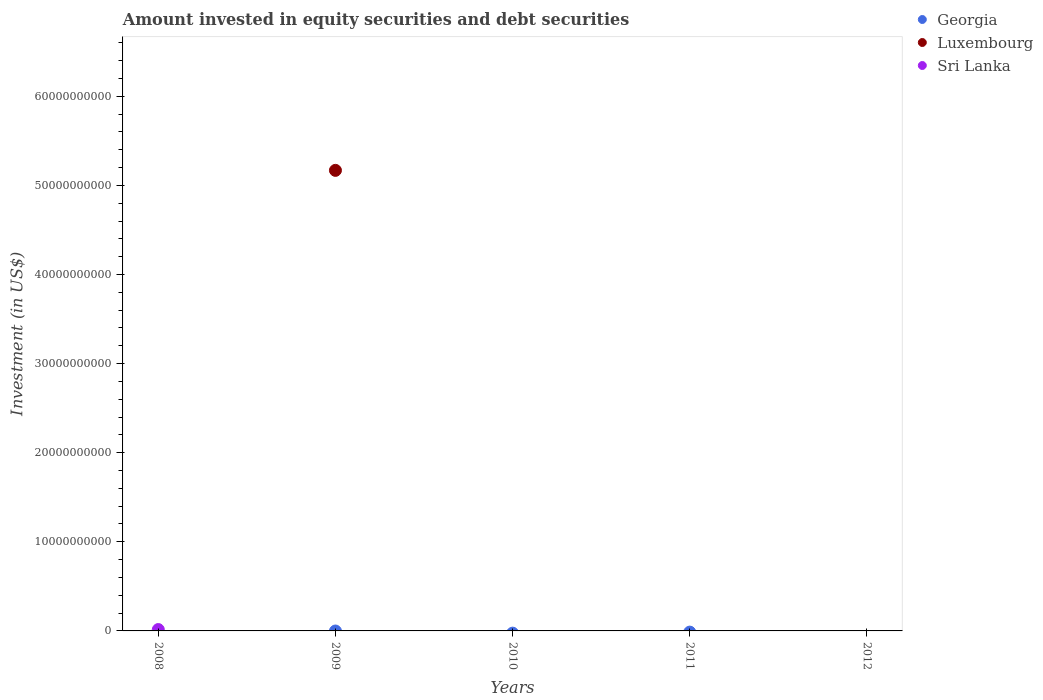Is the number of dotlines equal to the number of legend labels?
Ensure brevity in your answer.  No. What is the amount invested in equity securities and debt securities in Sri Lanka in 2012?
Offer a very short reply. 0. Across all years, what is the maximum amount invested in equity securities and debt securities in Luxembourg?
Provide a succinct answer. 5.17e+1. In which year was the amount invested in equity securities and debt securities in Sri Lanka maximum?
Provide a succinct answer. 2008. What is the total amount invested in equity securities and debt securities in Sri Lanka in the graph?
Give a very brief answer. 1.53e+08. What is the average amount invested in equity securities and debt securities in Luxembourg per year?
Give a very brief answer. 1.03e+1. What is the difference between the highest and the lowest amount invested in equity securities and debt securities in Luxembourg?
Offer a very short reply. 5.17e+1. Is the amount invested in equity securities and debt securities in Georgia strictly less than the amount invested in equity securities and debt securities in Luxembourg over the years?
Your answer should be compact. No. How many years are there in the graph?
Offer a terse response. 5. What is the difference between two consecutive major ticks on the Y-axis?
Your answer should be very brief. 1.00e+1. Are the values on the major ticks of Y-axis written in scientific E-notation?
Offer a terse response. No. Does the graph contain any zero values?
Provide a short and direct response. Yes. Does the graph contain grids?
Offer a very short reply. No. How are the legend labels stacked?
Provide a succinct answer. Vertical. What is the title of the graph?
Provide a short and direct response. Amount invested in equity securities and debt securities. What is the label or title of the Y-axis?
Your answer should be very brief. Investment (in US$). What is the Investment (in US$) of Sri Lanka in 2008?
Your response must be concise. 1.53e+08. What is the Investment (in US$) of Georgia in 2009?
Give a very brief answer. 0. What is the Investment (in US$) of Luxembourg in 2009?
Give a very brief answer. 5.17e+1. What is the Investment (in US$) in Sri Lanka in 2009?
Offer a very short reply. 0. What is the Investment (in US$) of Sri Lanka in 2010?
Ensure brevity in your answer.  0. What is the Investment (in US$) of Sri Lanka in 2011?
Give a very brief answer. 0. What is the Investment (in US$) in Luxembourg in 2012?
Provide a short and direct response. 0. What is the Investment (in US$) of Sri Lanka in 2012?
Your answer should be very brief. 0. Across all years, what is the maximum Investment (in US$) of Luxembourg?
Your response must be concise. 5.17e+1. Across all years, what is the maximum Investment (in US$) in Sri Lanka?
Make the answer very short. 1.53e+08. What is the total Investment (in US$) in Georgia in the graph?
Provide a short and direct response. 0. What is the total Investment (in US$) in Luxembourg in the graph?
Offer a terse response. 5.17e+1. What is the total Investment (in US$) in Sri Lanka in the graph?
Provide a short and direct response. 1.53e+08. What is the average Investment (in US$) in Luxembourg per year?
Your answer should be compact. 1.03e+1. What is the average Investment (in US$) of Sri Lanka per year?
Provide a succinct answer. 3.07e+07. What is the difference between the highest and the lowest Investment (in US$) in Luxembourg?
Provide a succinct answer. 5.17e+1. What is the difference between the highest and the lowest Investment (in US$) of Sri Lanka?
Offer a terse response. 1.53e+08. 